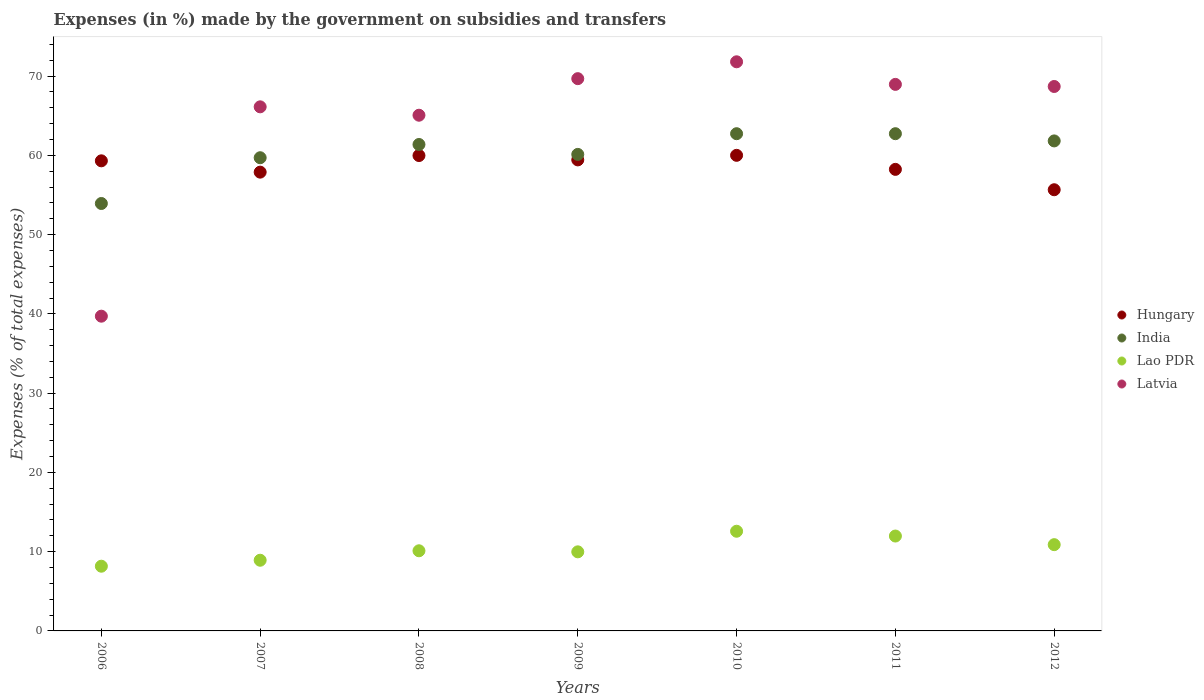What is the percentage of expenses made by the government on subsidies and transfers in India in 2008?
Ensure brevity in your answer.  61.37. Across all years, what is the maximum percentage of expenses made by the government on subsidies and transfers in Hungary?
Give a very brief answer. 60.01. Across all years, what is the minimum percentage of expenses made by the government on subsidies and transfers in Hungary?
Provide a short and direct response. 55.66. In which year was the percentage of expenses made by the government on subsidies and transfers in India minimum?
Your answer should be very brief. 2006. What is the total percentage of expenses made by the government on subsidies and transfers in Lao PDR in the graph?
Offer a very short reply. 72.6. What is the difference between the percentage of expenses made by the government on subsidies and transfers in India in 2009 and that in 2012?
Keep it short and to the point. -1.7. What is the difference between the percentage of expenses made by the government on subsidies and transfers in Lao PDR in 2010 and the percentage of expenses made by the government on subsidies and transfers in India in 2012?
Make the answer very short. -49.25. What is the average percentage of expenses made by the government on subsidies and transfers in India per year?
Ensure brevity in your answer.  60.35. In the year 2010, what is the difference between the percentage of expenses made by the government on subsidies and transfers in Latvia and percentage of expenses made by the government on subsidies and transfers in India?
Ensure brevity in your answer.  9.07. What is the ratio of the percentage of expenses made by the government on subsidies and transfers in Lao PDR in 2008 to that in 2011?
Provide a short and direct response. 0.84. What is the difference between the highest and the second highest percentage of expenses made by the government on subsidies and transfers in Lao PDR?
Your response must be concise. 0.6. What is the difference between the highest and the lowest percentage of expenses made by the government on subsidies and transfers in Latvia?
Keep it short and to the point. 32.1. Is the sum of the percentage of expenses made by the government on subsidies and transfers in India in 2007 and 2011 greater than the maximum percentage of expenses made by the government on subsidies and transfers in Hungary across all years?
Provide a short and direct response. Yes. Is it the case that in every year, the sum of the percentage of expenses made by the government on subsidies and transfers in India and percentage of expenses made by the government on subsidies and transfers in Latvia  is greater than the sum of percentage of expenses made by the government on subsidies and transfers in Lao PDR and percentage of expenses made by the government on subsidies and transfers in Hungary?
Make the answer very short. No. Does the percentage of expenses made by the government on subsidies and transfers in Lao PDR monotonically increase over the years?
Make the answer very short. No. Is the percentage of expenses made by the government on subsidies and transfers in India strictly greater than the percentage of expenses made by the government on subsidies and transfers in Hungary over the years?
Your answer should be compact. No. Is the percentage of expenses made by the government on subsidies and transfers in Hungary strictly less than the percentage of expenses made by the government on subsidies and transfers in India over the years?
Provide a succinct answer. No. How many dotlines are there?
Offer a very short reply. 4. What is the difference between two consecutive major ticks on the Y-axis?
Your response must be concise. 10. Are the values on the major ticks of Y-axis written in scientific E-notation?
Your answer should be very brief. No. Does the graph contain grids?
Your answer should be compact. No. Where does the legend appear in the graph?
Offer a very short reply. Center right. How are the legend labels stacked?
Your response must be concise. Vertical. What is the title of the graph?
Your answer should be compact. Expenses (in %) made by the government on subsidies and transfers. What is the label or title of the Y-axis?
Your response must be concise. Expenses (% of total expenses). What is the Expenses (% of total expenses) of Hungary in 2006?
Your answer should be very brief. 59.31. What is the Expenses (% of total expenses) of India in 2006?
Offer a terse response. 53.93. What is the Expenses (% of total expenses) of Lao PDR in 2006?
Ensure brevity in your answer.  8.16. What is the Expenses (% of total expenses) in Latvia in 2006?
Your answer should be very brief. 39.71. What is the Expenses (% of total expenses) of Hungary in 2007?
Give a very brief answer. 57.88. What is the Expenses (% of total expenses) in India in 2007?
Ensure brevity in your answer.  59.7. What is the Expenses (% of total expenses) in Lao PDR in 2007?
Provide a short and direct response. 8.92. What is the Expenses (% of total expenses) in Latvia in 2007?
Keep it short and to the point. 66.12. What is the Expenses (% of total expenses) of Hungary in 2008?
Provide a succinct answer. 59.98. What is the Expenses (% of total expenses) of India in 2008?
Your answer should be very brief. 61.37. What is the Expenses (% of total expenses) in Lao PDR in 2008?
Offer a terse response. 10.11. What is the Expenses (% of total expenses) in Latvia in 2008?
Your response must be concise. 65.07. What is the Expenses (% of total expenses) in Hungary in 2009?
Ensure brevity in your answer.  59.43. What is the Expenses (% of total expenses) in India in 2009?
Make the answer very short. 60.12. What is the Expenses (% of total expenses) of Lao PDR in 2009?
Your answer should be compact. 9.98. What is the Expenses (% of total expenses) in Latvia in 2009?
Keep it short and to the point. 69.68. What is the Expenses (% of total expenses) in Hungary in 2010?
Your answer should be compact. 60.01. What is the Expenses (% of total expenses) of India in 2010?
Your response must be concise. 62.73. What is the Expenses (% of total expenses) in Lao PDR in 2010?
Give a very brief answer. 12.58. What is the Expenses (% of total expenses) of Latvia in 2010?
Ensure brevity in your answer.  71.81. What is the Expenses (% of total expenses) in Hungary in 2011?
Keep it short and to the point. 58.23. What is the Expenses (% of total expenses) in India in 2011?
Make the answer very short. 62.73. What is the Expenses (% of total expenses) of Lao PDR in 2011?
Offer a terse response. 11.97. What is the Expenses (% of total expenses) of Latvia in 2011?
Your answer should be compact. 68.96. What is the Expenses (% of total expenses) in Hungary in 2012?
Your answer should be very brief. 55.66. What is the Expenses (% of total expenses) of India in 2012?
Give a very brief answer. 61.82. What is the Expenses (% of total expenses) in Lao PDR in 2012?
Your answer should be very brief. 10.88. What is the Expenses (% of total expenses) of Latvia in 2012?
Your answer should be very brief. 68.69. Across all years, what is the maximum Expenses (% of total expenses) in Hungary?
Your answer should be very brief. 60.01. Across all years, what is the maximum Expenses (% of total expenses) of India?
Offer a terse response. 62.73. Across all years, what is the maximum Expenses (% of total expenses) of Lao PDR?
Your response must be concise. 12.58. Across all years, what is the maximum Expenses (% of total expenses) of Latvia?
Provide a short and direct response. 71.81. Across all years, what is the minimum Expenses (% of total expenses) of Hungary?
Give a very brief answer. 55.66. Across all years, what is the minimum Expenses (% of total expenses) in India?
Ensure brevity in your answer.  53.93. Across all years, what is the minimum Expenses (% of total expenses) of Lao PDR?
Give a very brief answer. 8.16. Across all years, what is the minimum Expenses (% of total expenses) in Latvia?
Make the answer very short. 39.71. What is the total Expenses (% of total expenses) in Hungary in the graph?
Your answer should be very brief. 410.51. What is the total Expenses (% of total expenses) in India in the graph?
Make the answer very short. 422.42. What is the total Expenses (% of total expenses) of Lao PDR in the graph?
Offer a terse response. 72.6. What is the total Expenses (% of total expenses) in Latvia in the graph?
Make the answer very short. 450.04. What is the difference between the Expenses (% of total expenses) of Hungary in 2006 and that in 2007?
Make the answer very short. 1.43. What is the difference between the Expenses (% of total expenses) of India in 2006 and that in 2007?
Provide a short and direct response. -5.77. What is the difference between the Expenses (% of total expenses) of Lao PDR in 2006 and that in 2007?
Provide a short and direct response. -0.75. What is the difference between the Expenses (% of total expenses) of Latvia in 2006 and that in 2007?
Offer a very short reply. -26.41. What is the difference between the Expenses (% of total expenses) in Hungary in 2006 and that in 2008?
Your answer should be very brief. -0.67. What is the difference between the Expenses (% of total expenses) in India in 2006 and that in 2008?
Make the answer very short. -7.44. What is the difference between the Expenses (% of total expenses) of Lao PDR in 2006 and that in 2008?
Keep it short and to the point. -1.95. What is the difference between the Expenses (% of total expenses) of Latvia in 2006 and that in 2008?
Ensure brevity in your answer.  -25.36. What is the difference between the Expenses (% of total expenses) of Hungary in 2006 and that in 2009?
Ensure brevity in your answer.  -0.12. What is the difference between the Expenses (% of total expenses) in India in 2006 and that in 2009?
Provide a short and direct response. -6.19. What is the difference between the Expenses (% of total expenses) in Lao PDR in 2006 and that in 2009?
Provide a succinct answer. -1.81. What is the difference between the Expenses (% of total expenses) in Latvia in 2006 and that in 2009?
Ensure brevity in your answer.  -29.97. What is the difference between the Expenses (% of total expenses) of Hungary in 2006 and that in 2010?
Your answer should be very brief. -0.69. What is the difference between the Expenses (% of total expenses) in India in 2006 and that in 2010?
Your answer should be very brief. -8.81. What is the difference between the Expenses (% of total expenses) of Lao PDR in 2006 and that in 2010?
Your answer should be compact. -4.41. What is the difference between the Expenses (% of total expenses) of Latvia in 2006 and that in 2010?
Give a very brief answer. -32.1. What is the difference between the Expenses (% of total expenses) in Hungary in 2006 and that in 2011?
Offer a very short reply. 1.08. What is the difference between the Expenses (% of total expenses) of India in 2006 and that in 2011?
Keep it short and to the point. -8.81. What is the difference between the Expenses (% of total expenses) in Lao PDR in 2006 and that in 2011?
Keep it short and to the point. -3.81. What is the difference between the Expenses (% of total expenses) of Latvia in 2006 and that in 2011?
Provide a succinct answer. -29.25. What is the difference between the Expenses (% of total expenses) in Hungary in 2006 and that in 2012?
Your answer should be compact. 3.65. What is the difference between the Expenses (% of total expenses) of India in 2006 and that in 2012?
Your answer should be compact. -7.9. What is the difference between the Expenses (% of total expenses) of Lao PDR in 2006 and that in 2012?
Provide a succinct answer. -2.72. What is the difference between the Expenses (% of total expenses) in Latvia in 2006 and that in 2012?
Your response must be concise. -28.98. What is the difference between the Expenses (% of total expenses) in Hungary in 2007 and that in 2008?
Keep it short and to the point. -2.09. What is the difference between the Expenses (% of total expenses) in India in 2007 and that in 2008?
Ensure brevity in your answer.  -1.67. What is the difference between the Expenses (% of total expenses) of Lao PDR in 2007 and that in 2008?
Offer a terse response. -1.19. What is the difference between the Expenses (% of total expenses) in Latvia in 2007 and that in 2008?
Your answer should be compact. 1.06. What is the difference between the Expenses (% of total expenses) in Hungary in 2007 and that in 2009?
Ensure brevity in your answer.  -1.55. What is the difference between the Expenses (% of total expenses) of India in 2007 and that in 2009?
Provide a short and direct response. -0.42. What is the difference between the Expenses (% of total expenses) in Lao PDR in 2007 and that in 2009?
Provide a succinct answer. -1.06. What is the difference between the Expenses (% of total expenses) of Latvia in 2007 and that in 2009?
Offer a terse response. -3.55. What is the difference between the Expenses (% of total expenses) of Hungary in 2007 and that in 2010?
Ensure brevity in your answer.  -2.12. What is the difference between the Expenses (% of total expenses) of India in 2007 and that in 2010?
Offer a very short reply. -3.03. What is the difference between the Expenses (% of total expenses) in Lao PDR in 2007 and that in 2010?
Ensure brevity in your answer.  -3.66. What is the difference between the Expenses (% of total expenses) of Latvia in 2007 and that in 2010?
Your answer should be very brief. -5.68. What is the difference between the Expenses (% of total expenses) in Hungary in 2007 and that in 2011?
Offer a terse response. -0.35. What is the difference between the Expenses (% of total expenses) of India in 2007 and that in 2011?
Provide a short and direct response. -3.03. What is the difference between the Expenses (% of total expenses) in Lao PDR in 2007 and that in 2011?
Your answer should be compact. -3.05. What is the difference between the Expenses (% of total expenses) of Latvia in 2007 and that in 2011?
Provide a short and direct response. -2.83. What is the difference between the Expenses (% of total expenses) in Hungary in 2007 and that in 2012?
Your answer should be compact. 2.22. What is the difference between the Expenses (% of total expenses) in India in 2007 and that in 2012?
Give a very brief answer. -2.12. What is the difference between the Expenses (% of total expenses) of Lao PDR in 2007 and that in 2012?
Give a very brief answer. -1.97. What is the difference between the Expenses (% of total expenses) in Latvia in 2007 and that in 2012?
Offer a terse response. -2.57. What is the difference between the Expenses (% of total expenses) in Hungary in 2008 and that in 2009?
Provide a short and direct response. 0.55. What is the difference between the Expenses (% of total expenses) of India in 2008 and that in 2009?
Keep it short and to the point. 1.25. What is the difference between the Expenses (% of total expenses) in Lao PDR in 2008 and that in 2009?
Provide a short and direct response. 0.13. What is the difference between the Expenses (% of total expenses) in Latvia in 2008 and that in 2009?
Offer a terse response. -4.61. What is the difference between the Expenses (% of total expenses) of Hungary in 2008 and that in 2010?
Offer a very short reply. -0.03. What is the difference between the Expenses (% of total expenses) of India in 2008 and that in 2010?
Offer a very short reply. -1.36. What is the difference between the Expenses (% of total expenses) of Lao PDR in 2008 and that in 2010?
Ensure brevity in your answer.  -2.46. What is the difference between the Expenses (% of total expenses) of Latvia in 2008 and that in 2010?
Offer a very short reply. -6.74. What is the difference between the Expenses (% of total expenses) of Hungary in 2008 and that in 2011?
Provide a short and direct response. 1.74. What is the difference between the Expenses (% of total expenses) in India in 2008 and that in 2011?
Give a very brief answer. -1.36. What is the difference between the Expenses (% of total expenses) in Lao PDR in 2008 and that in 2011?
Offer a terse response. -1.86. What is the difference between the Expenses (% of total expenses) of Latvia in 2008 and that in 2011?
Your answer should be very brief. -3.89. What is the difference between the Expenses (% of total expenses) in Hungary in 2008 and that in 2012?
Your answer should be very brief. 4.31. What is the difference between the Expenses (% of total expenses) in India in 2008 and that in 2012?
Offer a very short reply. -0.45. What is the difference between the Expenses (% of total expenses) of Lao PDR in 2008 and that in 2012?
Offer a terse response. -0.77. What is the difference between the Expenses (% of total expenses) in Latvia in 2008 and that in 2012?
Offer a very short reply. -3.63. What is the difference between the Expenses (% of total expenses) in Hungary in 2009 and that in 2010?
Provide a succinct answer. -0.58. What is the difference between the Expenses (% of total expenses) of India in 2009 and that in 2010?
Ensure brevity in your answer.  -2.61. What is the difference between the Expenses (% of total expenses) in Lao PDR in 2009 and that in 2010?
Offer a terse response. -2.6. What is the difference between the Expenses (% of total expenses) of Latvia in 2009 and that in 2010?
Your answer should be compact. -2.13. What is the difference between the Expenses (% of total expenses) of Hungary in 2009 and that in 2011?
Provide a short and direct response. 1.2. What is the difference between the Expenses (% of total expenses) in India in 2009 and that in 2011?
Offer a very short reply. -2.61. What is the difference between the Expenses (% of total expenses) in Lao PDR in 2009 and that in 2011?
Ensure brevity in your answer.  -1.99. What is the difference between the Expenses (% of total expenses) of Latvia in 2009 and that in 2011?
Keep it short and to the point. 0.72. What is the difference between the Expenses (% of total expenses) of Hungary in 2009 and that in 2012?
Your answer should be compact. 3.77. What is the difference between the Expenses (% of total expenses) of India in 2009 and that in 2012?
Make the answer very short. -1.7. What is the difference between the Expenses (% of total expenses) in Lao PDR in 2009 and that in 2012?
Ensure brevity in your answer.  -0.91. What is the difference between the Expenses (% of total expenses) in Latvia in 2009 and that in 2012?
Your answer should be compact. 0.99. What is the difference between the Expenses (% of total expenses) of Hungary in 2010 and that in 2011?
Keep it short and to the point. 1.77. What is the difference between the Expenses (% of total expenses) in India in 2010 and that in 2011?
Offer a very short reply. 0. What is the difference between the Expenses (% of total expenses) in Lao PDR in 2010 and that in 2011?
Your answer should be compact. 0.6. What is the difference between the Expenses (% of total expenses) in Latvia in 2010 and that in 2011?
Give a very brief answer. 2.85. What is the difference between the Expenses (% of total expenses) in Hungary in 2010 and that in 2012?
Make the answer very short. 4.34. What is the difference between the Expenses (% of total expenses) of India in 2010 and that in 2012?
Keep it short and to the point. 0.91. What is the difference between the Expenses (% of total expenses) in Lao PDR in 2010 and that in 2012?
Make the answer very short. 1.69. What is the difference between the Expenses (% of total expenses) of Latvia in 2010 and that in 2012?
Offer a very short reply. 3.12. What is the difference between the Expenses (% of total expenses) of Hungary in 2011 and that in 2012?
Make the answer very short. 2.57. What is the difference between the Expenses (% of total expenses) of India in 2011 and that in 2012?
Provide a succinct answer. 0.91. What is the difference between the Expenses (% of total expenses) of Lao PDR in 2011 and that in 2012?
Provide a short and direct response. 1.09. What is the difference between the Expenses (% of total expenses) in Latvia in 2011 and that in 2012?
Your answer should be very brief. 0.27. What is the difference between the Expenses (% of total expenses) of Hungary in 2006 and the Expenses (% of total expenses) of India in 2007?
Provide a short and direct response. -0.39. What is the difference between the Expenses (% of total expenses) in Hungary in 2006 and the Expenses (% of total expenses) in Lao PDR in 2007?
Provide a short and direct response. 50.39. What is the difference between the Expenses (% of total expenses) of Hungary in 2006 and the Expenses (% of total expenses) of Latvia in 2007?
Your answer should be compact. -6.81. What is the difference between the Expenses (% of total expenses) in India in 2006 and the Expenses (% of total expenses) in Lao PDR in 2007?
Your response must be concise. 45.01. What is the difference between the Expenses (% of total expenses) in India in 2006 and the Expenses (% of total expenses) in Latvia in 2007?
Offer a terse response. -12.2. What is the difference between the Expenses (% of total expenses) of Lao PDR in 2006 and the Expenses (% of total expenses) of Latvia in 2007?
Keep it short and to the point. -57.96. What is the difference between the Expenses (% of total expenses) of Hungary in 2006 and the Expenses (% of total expenses) of India in 2008?
Your answer should be compact. -2.06. What is the difference between the Expenses (% of total expenses) in Hungary in 2006 and the Expenses (% of total expenses) in Lao PDR in 2008?
Offer a very short reply. 49.2. What is the difference between the Expenses (% of total expenses) in Hungary in 2006 and the Expenses (% of total expenses) in Latvia in 2008?
Give a very brief answer. -5.75. What is the difference between the Expenses (% of total expenses) in India in 2006 and the Expenses (% of total expenses) in Lao PDR in 2008?
Keep it short and to the point. 43.82. What is the difference between the Expenses (% of total expenses) in India in 2006 and the Expenses (% of total expenses) in Latvia in 2008?
Provide a succinct answer. -11.14. What is the difference between the Expenses (% of total expenses) of Lao PDR in 2006 and the Expenses (% of total expenses) of Latvia in 2008?
Your answer should be very brief. -56.9. What is the difference between the Expenses (% of total expenses) of Hungary in 2006 and the Expenses (% of total expenses) of India in 2009?
Ensure brevity in your answer.  -0.81. What is the difference between the Expenses (% of total expenses) in Hungary in 2006 and the Expenses (% of total expenses) in Lao PDR in 2009?
Ensure brevity in your answer.  49.33. What is the difference between the Expenses (% of total expenses) of Hungary in 2006 and the Expenses (% of total expenses) of Latvia in 2009?
Provide a short and direct response. -10.37. What is the difference between the Expenses (% of total expenses) in India in 2006 and the Expenses (% of total expenses) in Lao PDR in 2009?
Provide a succinct answer. 43.95. What is the difference between the Expenses (% of total expenses) of India in 2006 and the Expenses (% of total expenses) of Latvia in 2009?
Give a very brief answer. -15.75. What is the difference between the Expenses (% of total expenses) of Lao PDR in 2006 and the Expenses (% of total expenses) of Latvia in 2009?
Offer a terse response. -61.51. What is the difference between the Expenses (% of total expenses) in Hungary in 2006 and the Expenses (% of total expenses) in India in 2010?
Provide a succinct answer. -3.42. What is the difference between the Expenses (% of total expenses) in Hungary in 2006 and the Expenses (% of total expenses) in Lao PDR in 2010?
Offer a terse response. 46.74. What is the difference between the Expenses (% of total expenses) of Hungary in 2006 and the Expenses (% of total expenses) of Latvia in 2010?
Offer a very short reply. -12.49. What is the difference between the Expenses (% of total expenses) in India in 2006 and the Expenses (% of total expenses) in Lao PDR in 2010?
Keep it short and to the point. 41.35. What is the difference between the Expenses (% of total expenses) of India in 2006 and the Expenses (% of total expenses) of Latvia in 2010?
Offer a terse response. -17.88. What is the difference between the Expenses (% of total expenses) in Lao PDR in 2006 and the Expenses (% of total expenses) in Latvia in 2010?
Make the answer very short. -63.64. What is the difference between the Expenses (% of total expenses) in Hungary in 2006 and the Expenses (% of total expenses) in India in 2011?
Your answer should be compact. -3.42. What is the difference between the Expenses (% of total expenses) in Hungary in 2006 and the Expenses (% of total expenses) in Lao PDR in 2011?
Provide a short and direct response. 47.34. What is the difference between the Expenses (% of total expenses) of Hungary in 2006 and the Expenses (% of total expenses) of Latvia in 2011?
Your answer should be compact. -9.65. What is the difference between the Expenses (% of total expenses) in India in 2006 and the Expenses (% of total expenses) in Lao PDR in 2011?
Offer a terse response. 41.96. What is the difference between the Expenses (% of total expenses) in India in 2006 and the Expenses (% of total expenses) in Latvia in 2011?
Offer a terse response. -15.03. What is the difference between the Expenses (% of total expenses) in Lao PDR in 2006 and the Expenses (% of total expenses) in Latvia in 2011?
Ensure brevity in your answer.  -60.79. What is the difference between the Expenses (% of total expenses) in Hungary in 2006 and the Expenses (% of total expenses) in India in 2012?
Make the answer very short. -2.51. What is the difference between the Expenses (% of total expenses) in Hungary in 2006 and the Expenses (% of total expenses) in Lao PDR in 2012?
Your response must be concise. 48.43. What is the difference between the Expenses (% of total expenses) of Hungary in 2006 and the Expenses (% of total expenses) of Latvia in 2012?
Make the answer very short. -9.38. What is the difference between the Expenses (% of total expenses) in India in 2006 and the Expenses (% of total expenses) in Lao PDR in 2012?
Your answer should be very brief. 43.04. What is the difference between the Expenses (% of total expenses) in India in 2006 and the Expenses (% of total expenses) in Latvia in 2012?
Make the answer very short. -14.76. What is the difference between the Expenses (% of total expenses) in Lao PDR in 2006 and the Expenses (% of total expenses) in Latvia in 2012?
Your answer should be compact. -60.53. What is the difference between the Expenses (% of total expenses) in Hungary in 2007 and the Expenses (% of total expenses) in India in 2008?
Your answer should be very brief. -3.49. What is the difference between the Expenses (% of total expenses) in Hungary in 2007 and the Expenses (% of total expenses) in Lao PDR in 2008?
Ensure brevity in your answer.  47.77. What is the difference between the Expenses (% of total expenses) of Hungary in 2007 and the Expenses (% of total expenses) of Latvia in 2008?
Ensure brevity in your answer.  -7.18. What is the difference between the Expenses (% of total expenses) in India in 2007 and the Expenses (% of total expenses) in Lao PDR in 2008?
Offer a terse response. 49.59. What is the difference between the Expenses (% of total expenses) in India in 2007 and the Expenses (% of total expenses) in Latvia in 2008?
Give a very brief answer. -5.36. What is the difference between the Expenses (% of total expenses) in Lao PDR in 2007 and the Expenses (% of total expenses) in Latvia in 2008?
Your answer should be very brief. -56.15. What is the difference between the Expenses (% of total expenses) in Hungary in 2007 and the Expenses (% of total expenses) in India in 2009?
Provide a short and direct response. -2.24. What is the difference between the Expenses (% of total expenses) of Hungary in 2007 and the Expenses (% of total expenses) of Lao PDR in 2009?
Ensure brevity in your answer.  47.91. What is the difference between the Expenses (% of total expenses) of Hungary in 2007 and the Expenses (% of total expenses) of Latvia in 2009?
Provide a short and direct response. -11.79. What is the difference between the Expenses (% of total expenses) in India in 2007 and the Expenses (% of total expenses) in Lao PDR in 2009?
Give a very brief answer. 49.72. What is the difference between the Expenses (% of total expenses) of India in 2007 and the Expenses (% of total expenses) of Latvia in 2009?
Ensure brevity in your answer.  -9.98. What is the difference between the Expenses (% of total expenses) of Lao PDR in 2007 and the Expenses (% of total expenses) of Latvia in 2009?
Make the answer very short. -60.76. What is the difference between the Expenses (% of total expenses) of Hungary in 2007 and the Expenses (% of total expenses) of India in 2010?
Make the answer very short. -4.85. What is the difference between the Expenses (% of total expenses) in Hungary in 2007 and the Expenses (% of total expenses) in Lao PDR in 2010?
Your response must be concise. 45.31. What is the difference between the Expenses (% of total expenses) of Hungary in 2007 and the Expenses (% of total expenses) of Latvia in 2010?
Provide a short and direct response. -13.92. What is the difference between the Expenses (% of total expenses) of India in 2007 and the Expenses (% of total expenses) of Lao PDR in 2010?
Provide a short and direct response. 47.13. What is the difference between the Expenses (% of total expenses) in India in 2007 and the Expenses (% of total expenses) in Latvia in 2010?
Offer a very short reply. -12.1. What is the difference between the Expenses (% of total expenses) of Lao PDR in 2007 and the Expenses (% of total expenses) of Latvia in 2010?
Ensure brevity in your answer.  -62.89. What is the difference between the Expenses (% of total expenses) in Hungary in 2007 and the Expenses (% of total expenses) in India in 2011?
Ensure brevity in your answer.  -4.85. What is the difference between the Expenses (% of total expenses) in Hungary in 2007 and the Expenses (% of total expenses) in Lao PDR in 2011?
Keep it short and to the point. 45.91. What is the difference between the Expenses (% of total expenses) in Hungary in 2007 and the Expenses (% of total expenses) in Latvia in 2011?
Offer a very short reply. -11.07. What is the difference between the Expenses (% of total expenses) in India in 2007 and the Expenses (% of total expenses) in Lao PDR in 2011?
Ensure brevity in your answer.  47.73. What is the difference between the Expenses (% of total expenses) in India in 2007 and the Expenses (% of total expenses) in Latvia in 2011?
Provide a short and direct response. -9.26. What is the difference between the Expenses (% of total expenses) of Lao PDR in 2007 and the Expenses (% of total expenses) of Latvia in 2011?
Your answer should be very brief. -60.04. What is the difference between the Expenses (% of total expenses) in Hungary in 2007 and the Expenses (% of total expenses) in India in 2012?
Offer a very short reply. -3.94. What is the difference between the Expenses (% of total expenses) of Hungary in 2007 and the Expenses (% of total expenses) of Lao PDR in 2012?
Keep it short and to the point. 47. What is the difference between the Expenses (% of total expenses) in Hungary in 2007 and the Expenses (% of total expenses) in Latvia in 2012?
Offer a very short reply. -10.81. What is the difference between the Expenses (% of total expenses) in India in 2007 and the Expenses (% of total expenses) in Lao PDR in 2012?
Give a very brief answer. 48.82. What is the difference between the Expenses (% of total expenses) of India in 2007 and the Expenses (% of total expenses) of Latvia in 2012?
Give a very brief answer. -8.99. What is the difference between the Expenses (% of total expenses) in Lao PDR in 2007 and the Expenses (% of total expenses) in Latvia in 2012?
Provide a short and direct response. -59.77. What is the difference between the Expenses (% of total expenses) of Hungary in 2008 and the Expenses (% of total expenses) of India in 2009?
Keep it short and to the point. -0.14. What is the difference between the Expenses (% of total expenses) of Hungary in 2008 and the Expenses (% of total expenses) of Lao PDR in 2009?
Give a very brief answer. 50. What is the difference between the Expenses (% of total expenses) of Hungary in 2008 and the Expenses (% of total expenses) of Latvia in 2009?
Make the answer very short. -9.7. What is the difference between the Expenses (% of total expenses) in India in 2008 and the Expenses (% of total expenses) in Lao PDR in 2009?
Provide a succinct answer. 51.39. What is the difference between the Expenses (% of total expenses) of India in 2008 and the Expenses (% of total expenses) of Latvia in 2009?
Make the answer very short. -8.31. What is the difference between the Expenses (% of total expenses) in Lao PDR in 2008 and the Expenses (% of total expenses) in Latvia in 2009?
Your answer should be compact. -59.57. What is the difference between the Expenses (% of total expenses) of Hungary in 2008 and the Expenses (% of total expenses) of India in 2010?
Give a very brief answer. -2.76. What is the difference between the Expenses (% of total expenses) in Hungary in 2008 and the Expenses (% of total expenses) in Lao PDR in 2010?
Your answer should be very brief. 47.4. What is the difference between the Expenses (% of total expenses) in Hungary in 2008 and the Expenses (% of total expenses) in Latvia in 2010?
Provide a short and direct response. -11.83. What is the difference between the Expenses (% of total expenses) of India in 2008 and the Expenses (% of total expenses) of Lao PDR in 2010?
Keep it short and to the point. 48.8. What is the difference between the Expenses (% of total expenses) in India in 2008 and the Expenses (% of total expenses) in Latvia in 2010?
Keep it short and to the point. -10.43. What is the difference between the Expenses (% of total expenses) in Lao PDR in 2008 and the Expenses (% of total expenses) in Latvia in 2010?
Keep it short and to the point. -61.7. What is the difference between the Expenses (% of total expenses) of Hungary in 2008 and the Expenses (% of total expenses) of India in 2011?
Offer a very short reply. -2.76. What is the difference between the Expenses (% of total expenses) in Hungary in 2008 and the Expenses (% of total expenses) in Lao PDR in 2011?
Give a very brief answer. 48.01. What is the difference between the Expenses (% of total expenses) of Hungary in 2008 and the Expenses (% of total expenses) of Latvia in 2011?
Keep it short and to the point. -8.98. What is the difference between the Expenses (% of total expenses) of India in 2008 and the Expenses (% of total expenses) of Lao PDR in 2011?
Make the answer very short. 49.4. What is the difference between the Expenses (% of total expenses) of India in 2008 and the Expenses (% of total expenses) of Latvia in 2011?
Your answer should be compact. -7.58. What is the difference between the Expenses (% of total expenses) of Lao PDR in 2008 and the Expenses (% of total expenses) of Latvia in 2011?
Your response must be concise. -58.85. What is the difference between the Expenses (% of total expenses) of Hungary in 2008 and the Expenses (% of total expenses) of India in 2012?
Make the answer very short. -1.85. What is the difference between the Expenses (% of total expenses) in Hungary in 2008 and the Expenses (% of total expenses) in Lao PDR in 2012?
Your answer should be compact. 49.09. What is the difference between the Expenses (% of total expenses) in Hungary in 2008 and the Expenses (% of total expenses) in Latvia in 2012?
Offer a very short reply. -8.71. What is the difference between the Expenses (% of total expenses) of India in 2008 and the Expenses (% of total expenses) of Lao PDR in 2012?
Your response must be concise. 50.49. What is the difference between the Expenses (% of total expenses) in India in 2008 and the Expenses (% of total expenses) in Latvia in 2012?
Your answer should be compact. -7.32. What is the difference between the Expenses (% of total expenses) of Lao PDR in 2008 and the Expenses (% of total expenses) of Latvia in 2012?
Give a very brief answer. -58.58. What is the difference between the Expenses (% of total expenses) of Hungary in 2009 and the Expenses (% of total expenses) of India in 2010?
Provide a short and direct response. -3.3. What is the difference between the Expenses (% of total expenses) in Hungary in 2009 and the Expenses (% of total expenses) in Lao PDR in 2010?
Offer a terse response. 46.85. What is the difference between the Expenses (% of total expenses) of Hungary in 2009 and the Expenses (% of total expenses) of Latvia in 2010?
Your response must be concise. -12.38. What is the difference between the Expenses (% of total expenses) in India in 2009 and the Expenses (% of total expenses) in Lao PDR in 2010?
Offer a very short reply. 47.55. What is the difference between the Expenses (% of total expenses) of India in 2009 and the Expenses (% of total expenses) of Latvia in 2010?
Your response must be concise. -11.68. What is the difference between the Expenses (% of total expenses) of Lao PDR in 2009 and the Expenses (% of total expenses) of Latvia in 2010?
Ensure brevity in your answer.  -61.83. What is the difference between the Expenses (% of total expenses) in Hungary in 2009 and the Expenses (% of total expenses) in India in 2011?
Keep it short and to the point. -3.3. What is the difference between the Expenses (% of total expenses) in Hungary in 2009 and the Expenses (% of total expenses) in Lao PDR in 2011?
Your answer should be compact. 47.46. What is the difference between the Expenses (% of total expenses) of Hungary in 2009 and the Expenses (% of total expenses) of Latvia in 2011?
Give a very brief answer. -9.53. What is the difference between the Expenses (% of total expenses) in India in 2009 and the Expenses (% of total expenses) in Lao PDR in 2011?
Your response must be concise. 48.15. What is the difference between the Expenses (% of total expenses) in India in 2009 and the Expenses (% of total expenses) in Latvia in 2011?
Your answer should be very brief. -8.83. What is the difference between the Expenses (% of total expenses) of Lao PDR in 2009 and the Expenses (% of total expenses) of Latvia in 2011?
Your answer should be very brief. -58.98. What is the difference between the Expenses (% of total expenses) of Hungary in 2009 and the Expenses (% of total expenses) of India in 2012?
Make the answer very short. -2.39. What is the difference between the Expenses (% of total expenses) of Hungary in 2009 and the Expenses (% of total expenses) of Lao PDR in 2012?
Keep it short and to the point. 48.55. What is the difference between the Expenses (% of total expenses) of Hungary in 2009 and the Expenses (% of total expenses) of Latvia in 2012?
Ensure brevity in your answer.  -9.26. What is the difference between the Expenses (% of total expenses) of India in 2009 and the Expenses (% of total expenses) of Lao PDR in 2012?
Make the answer very short. 49.24. What is the difference between the Expenses (% of total expenses) of India in 2009 and the Expenses (% of total expenses) of Latvia in 2012?
Provide a succinct answer. -8.57. What is the difference between the Expenses (% of total expenses) of Lao PDR in 2009 and the Expenses (% of total expenses) of Latvia in 2012?
Ensure brevity in your answer.  -58.71. What is the difference between the Expenses (% of total expenses) in Hungary in 2010 and the Expenses (% of total expenses) in India in 2011?
Provide a succinct answer. -2.73. What is the difference between the Expenses (% of total expenses) of Hungary in 2010 and the Expenses (% of total expenses) of Lao PDR in 2011?
Your answer should be compact. 48.03. What is the difference between the Expenses (% of total expenses) of Hungary in 2010 and the Expenses (% of total expenses) of Latvia in 2011?
Give a very brief answer. -8.95. What is the difference between the Expenses (% of total expenses) of India in 2010 and the Expenses (% of total expenses) of Lao PDR in 2011?
Make the answer very short. 50.76. What is the difference between the Expenses (% of total expenses) of India in 2010 and the Expenses (% of total expenses) of Latvia in 2011?
Offer a terse response. -6.22. What is the difference between the Expenses (% of total expenses) of Lao PDR in 2010 and the Expenses (% of total expenses) of Latvia in 2011?
Your response must be concise. -56.38. What is the difference between the Expenses (% of total expenses) of Hungary in 2010 and the Expenses (% of total expenses) of India in 2012?
Your answer should be very brief. -1.82. What is the difference between the Expenses (% of total expenses) of Hungary in 2010 and the Expenses (% of total expenses) of Lao PDR in 2012?
Provide a short and direct response. 49.12. What is the difference between the Expenses (% of total expenses) in Hungary in 2010 and the Expenses (% of total expenses) in Latvia in 2012?
Offer a terse response. -8.69. What is the difference between the Expenses (% of total expenses) in India in 2010 and the Expenses (% of total expenses) in Lao PDR in 2012?
Your answer should be very brief. 51.85. What is the difference between the Expenses (% of total expenses) of India in 2010 and the Expenses (% of total expenses) of Latvia in 2012?
Offer a very short reply. -5.96. What is the difference between the Expenses (% of total expenses) in Lao PDR in 2010 and the Expenses (% of total expenses) in Latvia in 2012?
Ensure brevity in your answer.  -56.12. What is the difference between the Expenses (% of total expenses) in Hungary in 2011 and the Expenses (% of total expenses) in India in 2012?
Offer a terse response. -3.59. What is the difference between the Expenses (% of total expenses) of Hungary in 2011 and the Expenses (% of total expenses) of Lao PDR in 2012?
Offer a very short reply. 47.35. What is the difference between the Expenses (% of total expenses) of Hungary in 2011 and the Expenses (% of total expenses) of Latvia in 2012?
Give a very brief answer. -10.46. What is the difference between the Expenses (% of total expenses) in India in 2011 and the Expenses (% of total expenses) in Lao PDR in 2012?
Your answer should be very brief. 51.85. What is the difference between the Expenses (% of total expenses) of India in 2011 and the Expenses (% of total expenses) of Latvia in 2012?
Your answer should be very brief. -5.96. What is the difference between the Expenses (% of total expenses) of Lao PDR in 2011 and the Expenses (% of total expenses) of Latvia in 2012?
Your answer should be very brief. -56.72. What is the average Expenses (% of total expenses) of Hungary per year?
Your response must be concise. 58.64. What is the average Expenses (% of total expenses) in India per year?
Provide a succinct answer. 60.35. What is the average Expenses (% of total expenses) in Lao PDR per year?
Ensure brevity in your answer.  10.37. What is the average Expenses (% of total expenses) in Latvia per year?
Give a very brief answer. 64.29. In the year 2006, what is the difference between the Expenses (% of total expenses) of Hungary and Expenses (% of total expenses) of India?
Provide a short and direct response. 5.38. In the year 2006, what is the difference between the Expenses (% of total expenses) in Hungary and Expenses (% of total expenses) in Lao PDR?
Ensure brevity in your answer.  51.15. In the year 2006, what is the difference between the Expenses (% of total expenses) of Hungary and Expenses (% of total expenses) of Latvia?
Provide a short and direct response. 19.6. In the year 2006, what is the difference between the Expenses (% of total expenses) of India and Expenses (% of total expenses) of Lao PDR?
Offer a very short reply. 45.76. In the year 2006, what is the difference between the Expenses (% of total expenses) of India and Expenses (% of total expenses) of Latvia?
Offer a very short reply. 14.22. In the year 2006, what is the difference between the Expenses (% of total expenses) in Lao PDR and Expenses (% of total expenses) in Latvia?
Give a very brief answer. -31.55. In the year 2007, what is the difference between the Expenses (% of total expenses) in Hungary and Expenses (% of total expenses) in India?
Make the answer very short. -1.82. In the year 2007, what is the difference between the Expenses (% of total expenses) in Hungary and Expenses (% of total expenses) in Lao PDR?
Your answer should be very brief. 48.97. In the year 2007, what is the difference between the Expenses (% of total expenses) in Hungary and Expenses (% of total expenses) in Latvia?
Offer a terse response. -8.24. In the year 2007, what is the difference between the Expenses (% of total expenses) in India and Expenses (% of total expenses) in Lao PDR?
Ensure brevity in your answer.  50.78. In the year 2007, what is the difference between the Expenses (% of total expenses) of India and Expenses (% of total expenses) of Latvia?
Offer a terse response. -6.42. In the year 2007, what is the difference between the Expenses (% of total expenses) in Lao PDR and Expenses (% of total expenses) in Latvia?
Your answer should be compact. -57.21. In the year 2008, what is the difference between the Expenses (% of total expenses) in Hungary and Expenses (% of total expenses) in India?
Keep it short and to the point. -1.39. In the year 2008, what is the difference between the Expenses (% of total expenses) in Hungary and Expenses (% of total expenses) in Lao PDR?
Offer a terse response. 49.87. In the year 2008, what is the difference between the Expenses (% of total expenses) in Hungary and Expenses (% of total expenses) in Latvia?
Keep it short and to the point. -5.09. In the year 2008, what is the difference between the Expenses (% of total expenses) in India and Expenses (% of total expenses) in Lao PDR?
Your answer should be very brief. 51.26. In the year 2008, what is the difference between the Expenses (% of total expenses) of India and Expenses (% of total expenses) of Latvia?
Keep it short and to the point. -3.69. In the year 2008, what is the difference between the Expenses (% of total expenses) in Lao PDR and Expenses (% of total expenses) in Latvia?
Your answer should be very brief. -54.95. In the year 2009, what is the difference between the Expenses (% of total expenses) of Hungary and Expenses (% of total expenses) of India?
Offer a very short reply. -0.69. In the year 2009, what is the difference between the Expenses (% of total expenses) of Hungary and Expenses (% of total expenses) of Lao PDR?
Your answer should be compact. 49.45. In the year 2009, what is the difference between the Expenses (% of total expenses) in Hungary and Expenses (% of total expenses) in Latvia?
Make the answer very short. -10.25. In the year 2009, what is the difference between the Expenses (% of total expenses) in India and Expenses (% of total expenses) in Lao PDR?
Offer a very short reply. 50.14. In the year 2009, what is the difference between the Expenses (% of total expenses) in India and Expenses (% of total expenses) in Latvia?
Provide a short and direct response. -9.56. In the year 2009, what is the difference between the Expenses (% of total expenses) in Lao PDR and Expenses (% of total expenses) in Latvia?
Provide a short and direct response. -59.7. In the year 2010, what is the difference between the Expenses (% of total expenses) of Hungary and Expenses (% of total expenses) of India?
Make the answer very short. -2.73. In the year 2010, what is the difference between the Expenses (% of total expenses) of Hungary and Expenses (% of total expenses) of Lao PDR?
Your answer should be very brief. 47.43. In the year 2010, what is the difference between the Expenses (% of total expenses) in Hungary and Expenses (% of total expenses) in Latvia?
Your answer should be compact. -11.8. In the year 2010, what is the difference between the Expenses (% of total expenses) in India and Expenses (% of total expenses) in Lao PDR?
Give a very brief answer. 50.16. In the year 2010, what is the difference between the Expenses (% of total expenses) of India and Expenses (% of total expenses) of Latvia?
Make the answer very short. -9.07. In the year 2010, what is the difference between the Expenses (% of total expenses) in Lao PDR and Expenses (% of total expenses) in Latvia?
Your response must be concise. -59.23. In the year 2011, what is the difference between the Expenses (% of total expenses) in Hungary and Expenses (% of total expenses) in India?
Provide a succinct answer. -4.5. In the year 2011, what is the difference between the Expenses (% of total expenses) of Hungary and Expenses (% of total expenses) of Lao PDR?
Keep it short and to the point. 46.26. In the year 2011, what is the difference between the Expenses (% of total expenses) in Hungary and Expenses (% of total expenses) in Latvia?
Your answer should be very brief. -10.72. In the year 2011, what is the difference between the Expenses (% of total expenses) in India and Expenses (% of total expenses) in Lao PDR?
Offer a very short reply. 50.76. In the year 2011, what is the difference between the Expenses (% of total expenses) of India and Expenses (% of total expenses) of Latvia?
Provide a short and direct response. -6.22. In the year 2011, what is the difference between the Expenses (% of total expenses) of Lao PDR and Expenses (% of total expenses) of Latvia?
Make the answer very short. -56.99. In the year 2012, what is the difference between the Expenses (% of total expenses) in Hungary and Expenses (% of total expenses) in India?
Make the answer very short. -6.16. In the year 2012, what is the difference between the Expenses (% of total expenses) in Hungary and Expenses (% of total expenses) in Lao PDR?
Your answer should be very brief. 44.78. In the year 2012, what is the difference between the Expenses (% of total expenses) of Hungary and Expenses (% of total expenses) of Latvia?
Make the answer very short. -13.03. In the year 2012, what is the difference between the Expenses (% of total expenses) in India and Expenses (% of total expenses) in Lao PDR?
Your response must be concise. 50.94. In the year 2012, what is the difference between the Expenses (% of total expenses) of India and Expenses (% of total expenses) of Latvia?
Provide a succinct answer. -6.87. In the year 2012, what is the difference between the Expenses (% of total expenses) of Lao PDR and Expenses (% of total expenses) of Latvia?
Your response must be concise. -57.81. What is the ratio of the Expenses (% of total expenses) of Hungary in 2006 to that in 2007?
Give a very brief answer. 1.02. What is the ratio of the Expenses (% of total expenses) of India in 2006 to that in 2007?
Provide a succinct answer. 0.9. What is the ratio of the Expenses (% of total expenses) of Lao PDR in 2006 to that in 2007?
Your answer should be compact. 0.92. What is the ratio of the Expenses (% of total expenses) in Latvia in 2006 to that in 2007?
Keep it short and to the point. 0.6. What is the ratio of the Expenses (% of total expenses) in Hungary in 2006 to that in 2008?
Your answer should be very brief. 0.99. What is the ratio of the Expenses (% of total expenses) in India in 2006 to that in 2008?
Offer a very short reply. 0.88. What is the ratio of the Expenses (% of total expenses) of Lao PDR in 2006 to that in 2008?
Provide a succinct answer. 0.81. What is the ratio of the Expenses (% of total expenses) in Latvia in 2006 to that in 2008?
Your answer should be very brief. 0.61. What is the ratio of the Expenses (% of total expenses) of Hungary in 2006 to that in 2009?
Your answer should be compact. 1. What is the ratio of the Expenses (% of total expenses) of India in 2006 to that in 2009?
Offer a terse response. 0.9. What is the ratio of the Expenses (% of total expenses) of Lao PDR in 2006 to that in 2009?
Offer a very short reply. 0.82. What is the ratio of the Expenses (% of total expenses) of Latvia in 2006 to that in 2009?
Ensure brevity in your answer.  0.57. What is the ratio of the Expenses (% of total expenses) in Hungary in 2006 to that in 2010?
Provide a short and direct response. 0.99. What is the ratio of the Expenses (% of total expenses) in India in 2006 to that in 2010?
Keep it short and to the point. 0.86. What is the ratio of the Expenses (% of total expenses) of Lao PDR in 2006 to that in 2010?
Give a very brief answer. 0.65. What is the ratio of the Expenses (% of total expenses) in Latvia in 2006 to that in 2010?
Give a very brief answer. 0.55. What is the ratio of the Expenses (% of total expenses) of Hungary in 2006 to that in 2011?
Provide a short and direct response. 1.02. What is the ratio of the Expenses (% of total expenses) in India in 2006 to that in 2011?
Provide a succinct answer. 0.86. What is the ratio of the Expenses (% of total expenses) in Lao PDR in 2006 to that in 2011?
Give a very brief answer. 0.68. What is the ratio of the Expenses (% of total expenses) of Latvia in 2006 to that in 2011?
Provide a succinct answer. 0.58. What is the ratio of the Expenses (% of total expenses) of Hungary in 2006 to that in 2012?
Provide a short and direct response. 1.07. What is the ratio of the Expenses (% of total expenses) of India in 2006 to that in 2012?
Your answer should be very brief. 0.87. What is the ratio of the Expenses (% of total expenses) in Lao PDR in 2006 to that in 2012?
Offer a terse response. 0.75. What is the ratio of the Expenses (% of total expenses) of Latvia in 2006 to that in 2012?
Keep it short and to the point. 0.58. What is the ratio of the Expenses (% of total expenses) in Hungary in 2007 to that in 2008?
Your response must be concise. 0.97. What is the ratio of the Expenses (% of total expenses) in India in 2007 to that in 2008?
Make the answer very short. 0.97. What is the ratio of the Expenses (% of total expenses) of Lao PDR in 2007 to that in 2008?
Keep it short and to the point. 0.88. What is the ratio of the Expenses (% of total expenses) in Latvia in 2007 to that in 2008?
Make the answer very short. 1.02. What is the ratio of the Expenses (% of total expenses) of India in 2007 to that in 2009?
Give a very brief answer. 0.99. What is the ratio of the Expenses (% of total expenses) of Lao PDR in 2007 to that in 2009?
Offer a terse response. 0.89. What is the ratio of the Expenses (% of total expenses) of Latvia in 2007 to that in 2009?
Your answer should be very brief. 0.95. What is the ratio of the Expenses (% of total expenses) in Hungary in 2007 to that in 2010?
Provide a short and direct response. 0.96. What is the ratio of the Expenses (% of total expenses) of India in 2007 to that in 2010?
Provide a short and direct response. 0.95. What is the ratio of the Expenses (% of total expenses) of Lao PDR in 2007 to that in 2010?
Your response must be concise. 0.71. What is the ratio of the Expenses (% of total expenses) of Latvia in 2007 to that in 2010?
Ensure brevity in your answer.  0.92. What is the ratio of the Expenses (% of total expenses) of Hungary in 2007 to that in 2011?
Make the answer very short. 0.99. What is the ratio of the Expenses (% of total expenses) of India in 2007 to that in 2011?
Keep it short and to the point. 0.95. What is the ratio of the Expenses (% of total expenses) in Lao PDR in 2007 to that in 2011?
Ensure brevity in your answer.  0.74. What is the ratio of the Expenses (% of total expenses) in Latvia in 2007 to that in 2011?
Offer a terse response. 0.96. What is the ratio of the Expenses (% of total expenses) of Hungary in 2007 to that in 2012?
Your answer should be very brief. 1.04. What is the ratio of the Expenses (% of total expenses) in India in 2007 to that in 2012?
Provide a succinct answer. 0.97. What is the ratio of the Expenses (% of total expenses) of Lao PDR in 2007 to that in 2012?
Keep it short and to the point. 0.82. What is the ratio of the Expenses (% of total expenses) in Latvia in 2007 to that in 2012?
Provide a short and direct response. 0.96. What is the ratio of the Expenses (% of total expenses) in Hungary in 2008 to that in 2009?
Give a very brief answer. 1.01. What is the ratio of the Expenses (% of total expenses) in India in 2008 to that in 2009?
Your response must be concise. 1.02. What is the ratio of the Expenses (% of total expenses) in Lao PDR in 2008 to that in 2009?
Your response must be concise. 1.01. What is the ratio of the Expenses (% of total expenses) in Latvia in 2008 to that in 2009?
Provide a succinct answer. 0.93. What is the ratio of the Expenses (% of total expenses) in India in 2008 to that in 2010?
Offer a very short reply. 0.98. What is the ratio of the Expenses (% of total expenses) in Lao PDR in 2008 to that in 2010?
Make the answer very short. 0.8. What is the ratio of the Expenses (% of total expenses) in Latvia in 2008 to that in 2010?
Keep it short and to the point. 0.91. What is the ratio of the Expenses (% of total expenses) in Hungary in 2008 to that in 2011?
Ensure brevity in your answer.  1.03. What is the ratio of the Expenses (% of total expenses) of India in 2008 to that in 2011?
Offer a terse response. 0.98. What is the ratio of the Expenses (% of total expenses) in Lao PDR in 2008 to that in 2011?
Offer a terse response. 0.84. What is the ratio of the Expenses (% of total expenses) of Latvia in 2008 to that in 2011?
Your response must be concise. 0.94. What is the ratio of the Expenses (% of total expenses) of Hungary in 2008 to that in 2012?
Give a very brief answer. 1.08. What is the ratio of the Expenses (% of total expenses) in India in 2008 to that in 2012?
Make the answer very short. 0.99. What is the ratio of the Expenses (% of total expenses) in Lao PDR in 2008 to that in 2012?
Give a very brief answer. 0.93. What is the ratio of the Expenses (% of total expenses) in Latvia in 2008 to that in 2012?
Provide a short and direct response. 0.95. What is the ratio of the Expenses (% of total expenses) in India in 2009 to that in 2010?
Provide a succinct answer. 0.96. What is the ratio of the Expenses (% of total expenses) of Lao PDR in 2009 to that in 2010?
Offer a terse response. 0.79. What is the ratio of the Expenses (% of total expenses) of Latvia in 2009 to that in 2010?
Your response must be concise. 0.97. What is the ratio of the Expenses (% of total expenses) in Hungary in 2009 to that in 2011?
Provide a short and direct response. 1.02. What is the ratio of the Expenses (% of total expenses) in India in 2009 to that in 2011?
Offer a very short reply. 0.96. What is the ratio of the Expenses (% of total expenses) of Lao PDR in 2009 to that in 2011?
Ensure brevity in your answer.  0.83. What is the ratio of the Expenses (% of total expenses) in Latvia in 2009 to that in 2011?
Offer a terse response. 1.01. What is the ratio of the Expenses (% of total expenses) in Hungary in 2009 to that in 2012?
Your response must be concise. 1.07. What is the ratio of the Expenses (% of total expenses) in India in 2009 to that in 2012?
Your response must be concise. 0.97. What is the ratio of the Expenses (% of total expenses) in Lao PDR in 2009 to that in 2012?
Provide a succinct answer. 0.92. What is the ratio of the Expenses (% of total expenses) of Latvia in 2009 to that in 2012?
Your answer should be very brief. 1.01. What is the ratio of the Expenses (% of total expenses) in Hungary in 2010 to that in 2011?
Your response must be concise. 1.03. What is the ratio of the Expenses (% of total expenses) in India in 2010 to that in 2011?
Your response must be concise. 1. What is the ratio of the Expenses (% of total expenses) of Lao PDR in 2010 to that in 2011?
Your answer should be compact. 1.05. What is the ratio of the Expenses (% of total expenses) of Latvia in 2010 to that in 2011?
Keep it short and to the point. 1.04. What is the ratio of the Expenses (% of total expenses) in Hungary in 2010 to that in 2012?
Your response must be concise. 1.08. What is the ratio of the Expenses (% of total expenses) of India in 2010 to that in 2012?
Give a very brief answer. 1.01. What is the ratio of the Expenses (% of total expenses) of Lao PDR in 2010 to that in 2012?
Offer a terse response. 1.16. What is the ratio of the Expenses (% of total expenses) in Latvia in 2010 to that in 2012?
Ensure brevity in your answer.  1.05. What is the ratio of the Expenses (% of total expenses) in Hungary in 2011 to that in 2012?
Provide a succinct answer. 1.05. What is the ratio of the Expenses (% of total expenses) of India in 2011 to that in 2012?
Offer a very short reply. 1.01. What is the ratio of the Expenses (% of total expenses) in Lao PDR in 2011 to that in 2012?
Ensure brevity in your answer.  1.1. What is the ratio of the Expenses (% of total expenses) of Latvia in 2011 to that in 2012?
Provide a succinct answer. 1. What is the difference between the highest and the second highest Expenses (% of total expenses) of Hungary?
Offer a very short reply. 0.03. What is the difference between the highest and the second highest Expenses (% of total expenses) of India?
Your answer should be very brief. 0. What is the difference between the highest and the second highest Expenses (% of total expenses) of Lao PDR?
Your answer should be very brief. 0.6. What is the difference between the highest and the second highest Expenses (% of total expenses) in Latvia?
Offer a terse response. 2.13. What is the difference between the highest and the lowest Expenses (% of total expenses) in Hungary?
Provide a succinct answer. 4.34. What is the difference between the highest and the lowest Expenses (% of total expenses) in India?
Ensure brevity in your answer.  8.81. What is the difference between the highest and the lowest Expenses (% of total expenses) of Lao PDR?
Ensure brevity in your answer.  4.41. What is the difference between the highest and the lowest Expenses (% of total expenses) in Latvia?
Provide a short and direct response. 32.1. 